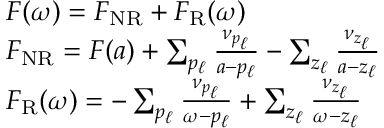Convert formula to latex. <formula><loc_0><loc_0><loc_500><loc_500>\begin{array} { r } { \begin{array} { r l } & { F ( \omega ) = F _ { N R } + F _ { R } ( \omega ) } \\ & { F _ { N R } = F ( a ) + \sum _ { p _ { \ell } } \frac { \nu _ { p _ { \ell } } } { a - p _ { \ell } } - \sum _ { z _ { \ell } } \frac { \nu _ { z _ { \ell } } } { a - z _ { \ell } } } \\ & { F _ { R } ( \omega ) = - \sum _ { p _ { \ell } } \frac { \nu _ { p _ { \ell } } } { \omega - p _ { \ell } } + \sum _ { z _ { \ell } } \frac { \nu _ { z _ { \ell } } } { \omega - z _ { \ell } } } \end{array} } \end{array}</formula> 